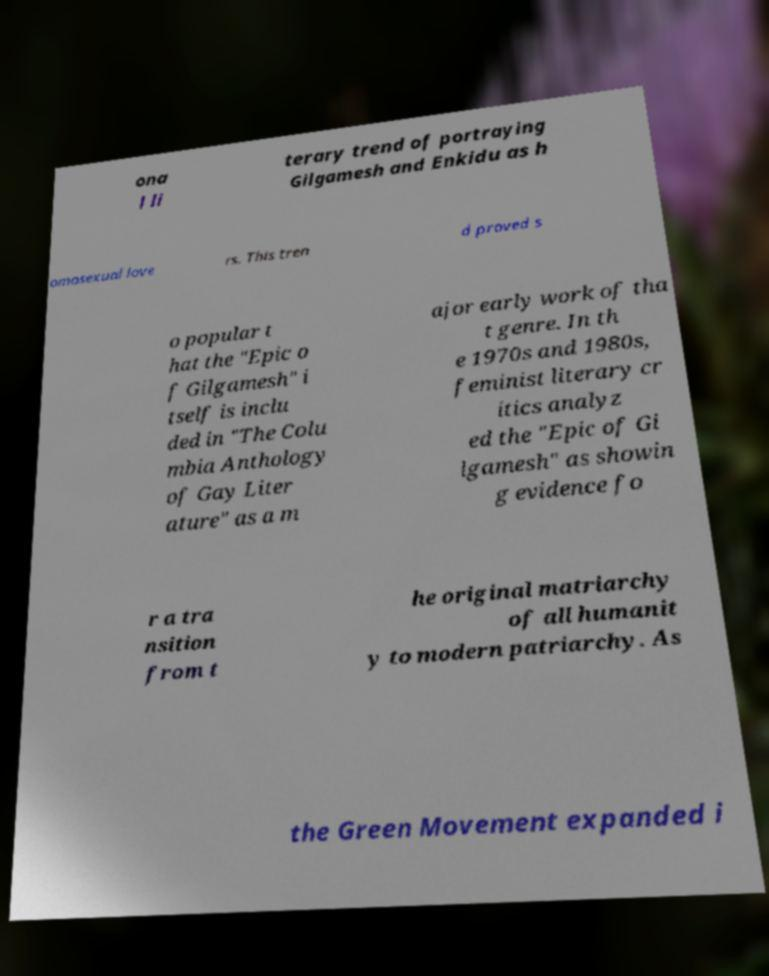What messages or text are displayed in this image? I need them in a readable, typed format. ona l li terary trend of portraying Gilgamesh and Enkidu as h omosexual love rs. This tren d proved s o popular t hat the "Epic o f Gilgamesh" i tself is inclu ded in "The Colu mbia Anthology of Gay Liter ature" as a m ajor early work of tha t genre. In th e 1970s and 1980s, feminist literary cr itics analyz ed the "Epic of Gi lgamesh" as showin g evidence fo r a tra nsition from t he original matriarchy of all humanit y to modern patriarchy. As the Green Movement expanded i 